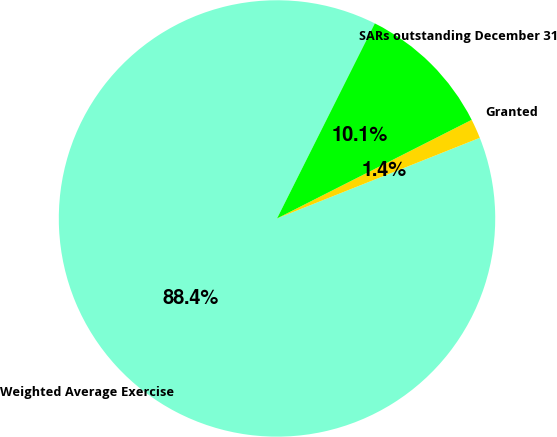<chart> <loc_0><loc_0><loc_500><loc_500><pie_chart><fcel>Weighted Average Exercise<fcel>Granted<fcel>SARs outstanding December 31<nl><fcel>88.43%<fcel>1.44%<fcel>10.14%<nl></chart> 